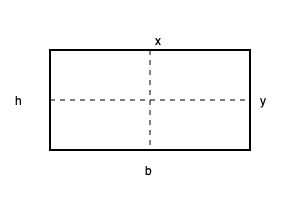Calculate the moment of inertia $I_x$ about the x-axis for a rectangular beam cross-section with a width $b = 6$ cm and a height $h = 12$ cm. To calculate the moment of inertia $I_x$ about the x-axis for a rectangular beam cross-section, we follow these steps:

1. Recall the formula for the moment of inertia of a rectangle about its centroidal x-axis:

   $$I_x = \frac{1}{12}bh^3$$

   Where:
   $b$ is the width of the rectangle
   $h$ is the height of the rectangle

2. Substitute the given values:
   $b = 6$ cm
   $h = 12$ cm

3. Calculate:

   $$I_x = \frac{1}{12} \times 6 \times 12^3$$
   
   $$I_x = \frac{1}{12} \times 6 \times 1728$$
   
   $$I_x = 864 \text{ cm}^4$$

Therefore, the moment of inertia $I_x$ about the x-axis for the given rectangular beam cross-section is 864 cm^4.
Answer: $864 \text{ cm}^4$ 